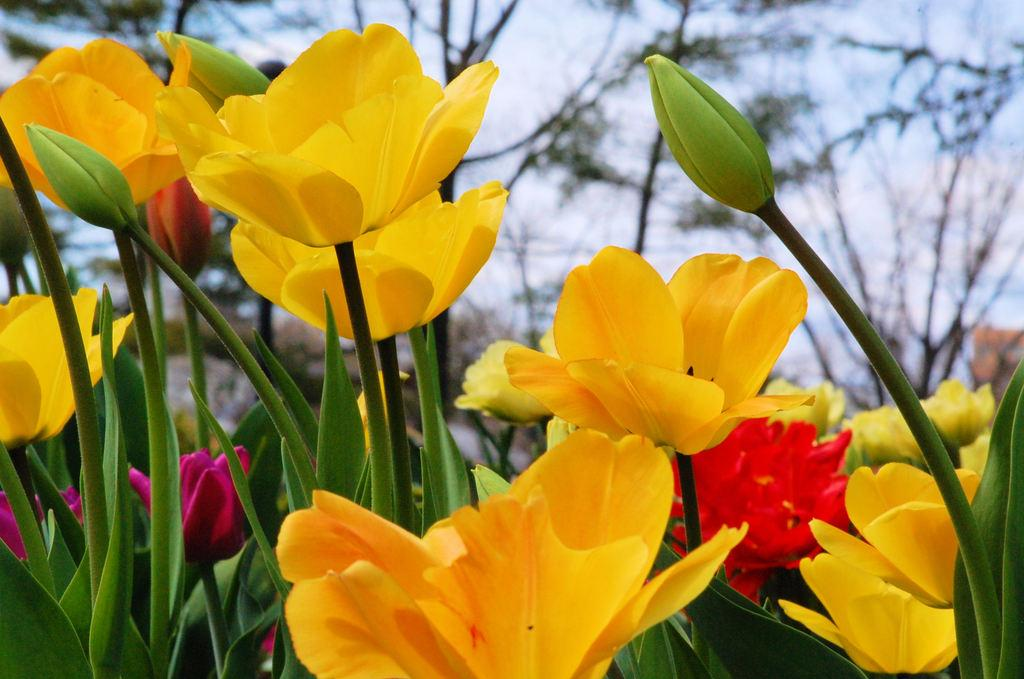What type of flora is present in the image? There are flowers in the image. What colors can be seen in the flowers? The flowers are yellow, red, and pink in color. What color are the plants in the image? The plants are green in color. What can be seen in the background of the image? There are trees and the sky visible in the background of the image. What type of bead is being used by the carpenter in the image? There is no carpenter or bead present in the image; it features flowers, plants, trees, and the sky. 